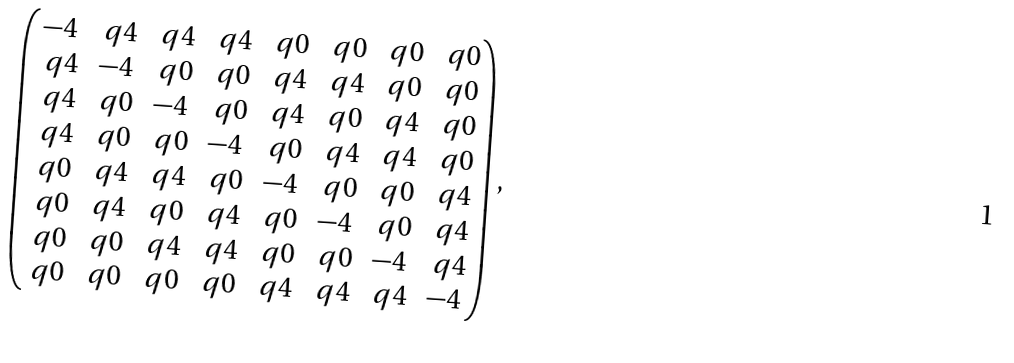Convert formula to latex. <formula><loc_0><loc_0><loc_500><loc_500>\left ( \begin{matrix} - 4 & \ q 4 & \ q 4 & \ q 4 & \ q 0 & \ q 0 & \ q 0 & \ q 0 \\ \ q 4 & - 4 & \ q 0 & \ q 0 & \ q 4 & \ q 4 & \ q 0 & \ q 0 \\ \ q 4 & \ q 0 & - 4 & \ q 0 & \ q 4 & \ q 0 & \ q 4 & \ q 0 \\ \ q 4 & \ q 0 & \ q 0 & - 4 & \ q 0 & \ q 4 & \ q 4 & \ q 0 \\ \ q 0 & \ q 4 & \ q 4 & \ q 0 & - 4 & \ q 0 & \ q 0 & \ q 4 \\ \ q 0 & \ q 4 & \ q 0 & \ q 4 & \ q 0 & - 4 & \ q 0 & \ q 4 \\ \ q 0 & \ q 0 & \ q 4 & \ q 4 & \ q 0 & \ q 0 & - 4 & \ q 4 \\ \ q 0 & \ q 0 & \ q 0 & \ q 0 & \ q 4 & \ q 4 & \ q 4 & - 4 \\ \end{matrix} \right ) ,</formula> 